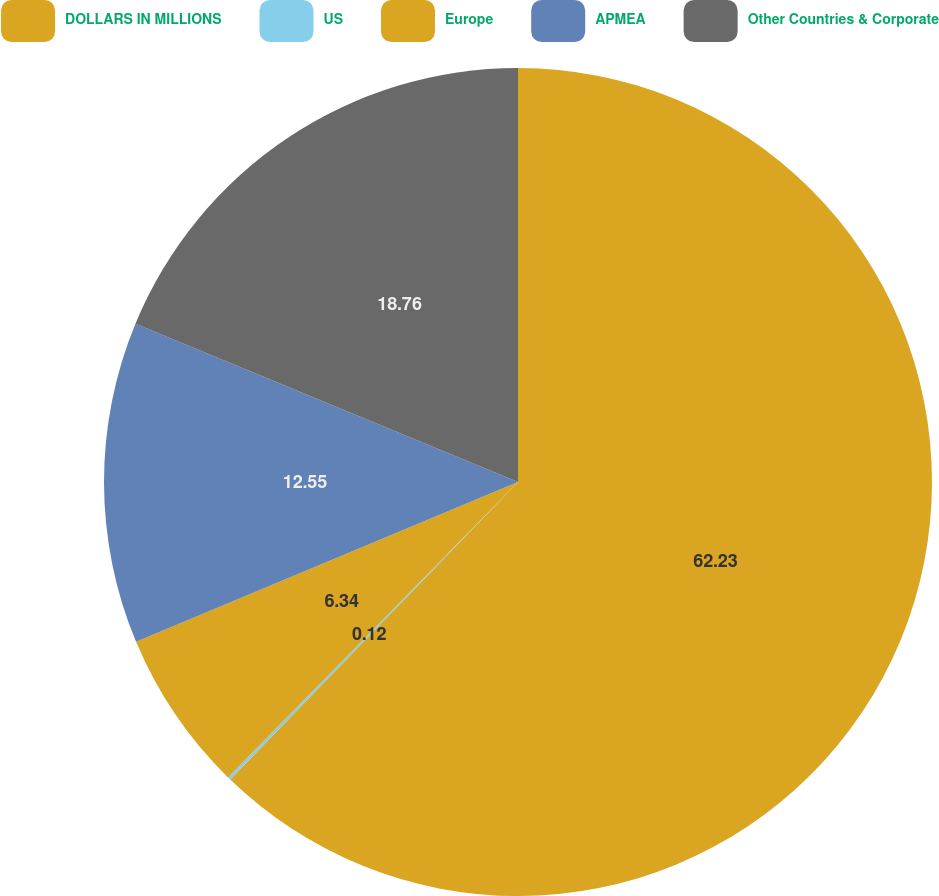Convert chart to OTSL. <chart><loc_0><loc_0><loc_500><loc_500><pie_chart><fcel>DOLLARS IN MILLIONS<fcel>US<fcel>Europe<fcel>APMEA<fcel>Other Countries & Corporate<nl><fcel>62.24%<fcel>0.12%<fcel>6.34%<fcel>12.55%<fcel>18.76%<nl></chart> 